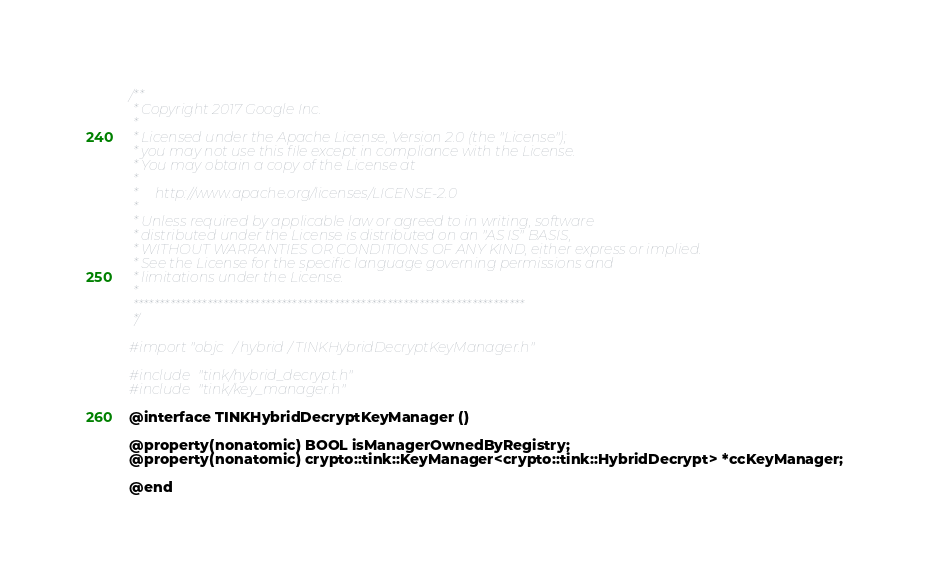<code> <loc_0><loc_0><loc_500><loc_500><_C_>/**
 * Copyright 2017 Google Inc.
 *
 * Licensed under the Apache License, Version 2.0 (the "License");
 * you may not use this file except in compliance with the License.
 * You may obtain a copy of the License at
 *
 *     http://www.apache.org/licenses/LICENSE-2.0
 *
 * Unless required by applicable law or agreed to in writing, software
 * distributed under the License is distributed on an "AS IS" BASIS,
 * WITHOUT WARRANTIES OR CONDITIONS OF ANY KIND, either express or implied.
 * See the License for the specific language governing permissions and
 * limitations under the License.
 *
 **************************************************************************
 */

#import "objc/hybrid/TINKHybridDecryptKeyManager.h"

#include "tink/hybrid_decrypt.h"
#include "tink/key_manager.h"

@interface TINKHybridDecryptKeyManager ()

@property(nonatomic) BOOL isManagerOwnedByRegistry;
@property(nonatomic) crypto::tink::KeyManager<crypto::tink::HybridDecrypt> *ccKeyManager;

@end
</code> 